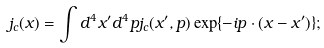<formula> <loc_0><loc_0><loc_500><loc_500>j _ { c } ( x ) = \int d ^ { 4 } x ^ { \prime } d ^ { 4 } p j _ { c } ( x ^ { \prime } , p ) \exp \{ - i p \cdot ( x - x ^ { \prime } ) \} ;</formula> 